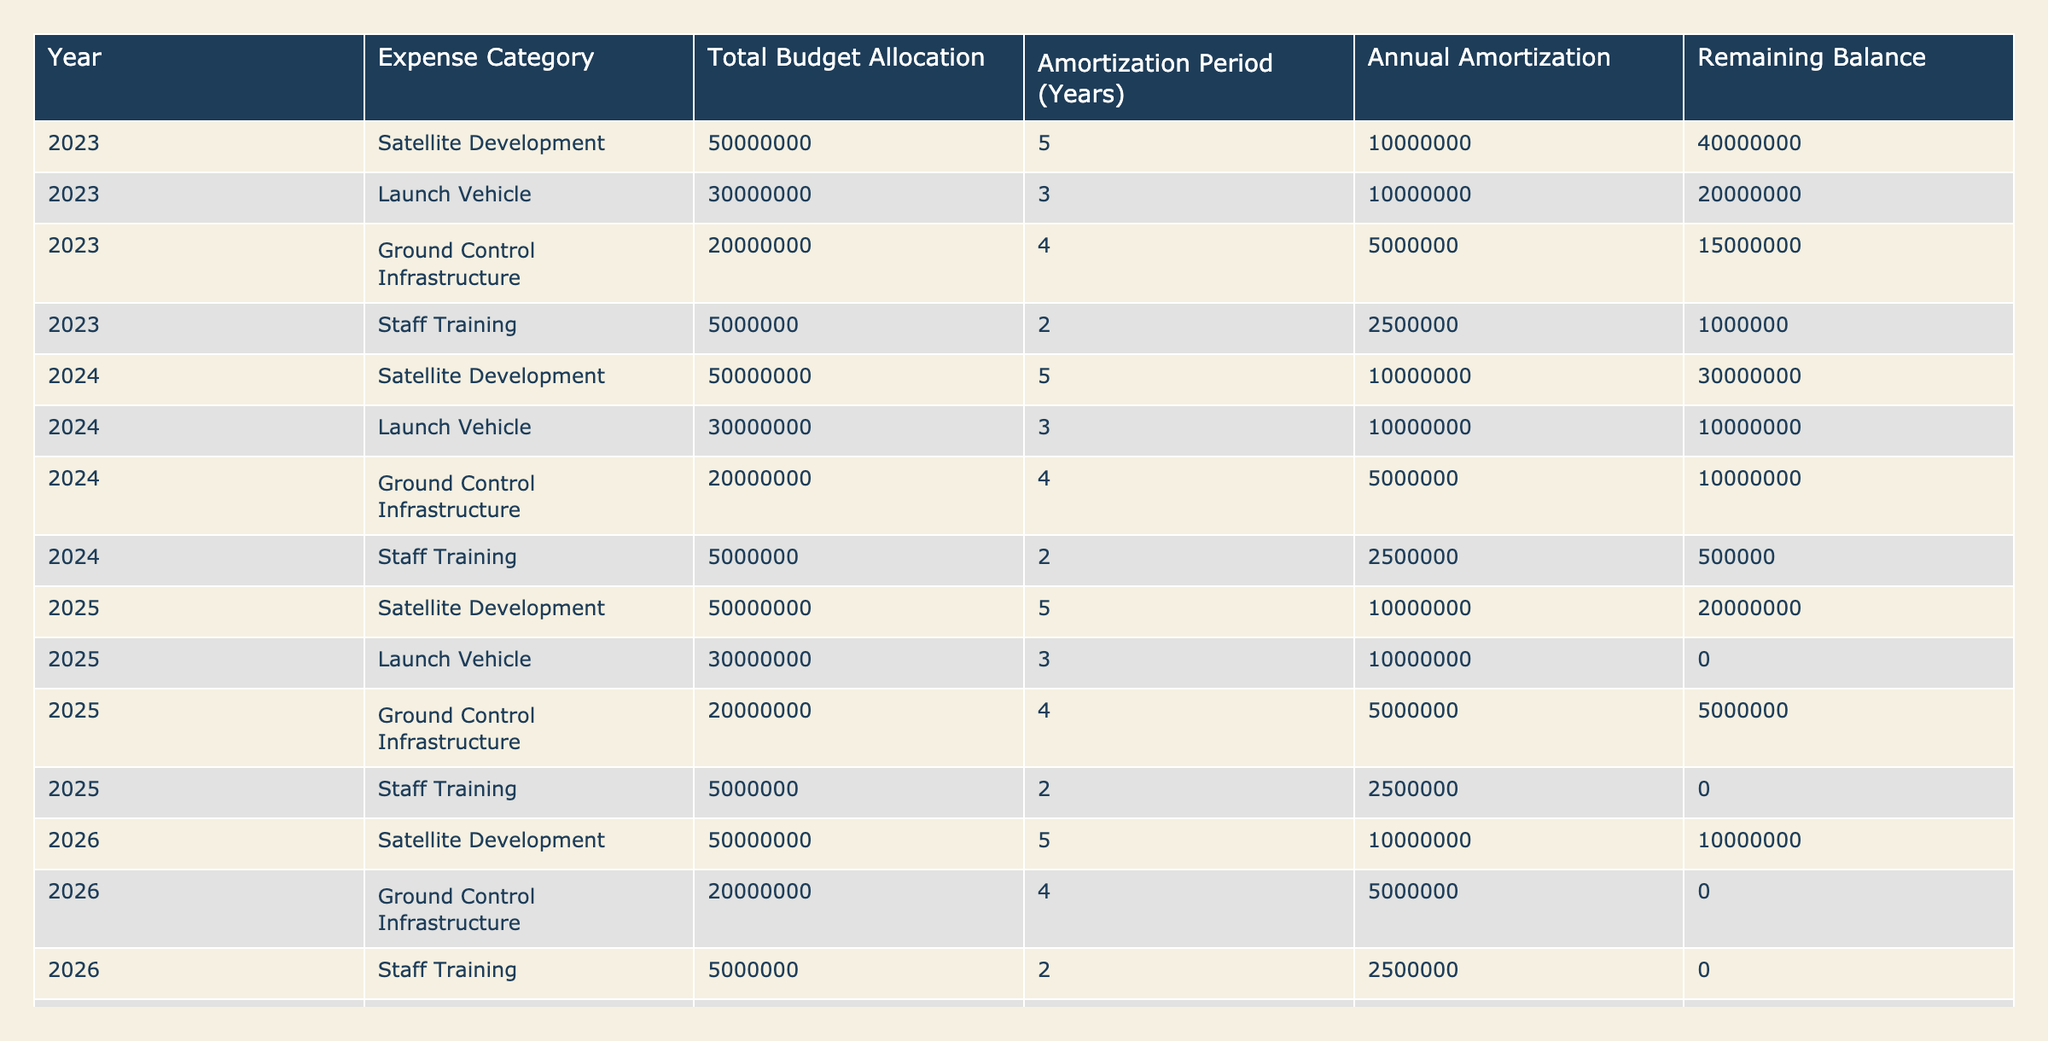What is the annual amortization for Satellite Development in 2023? In the table, we can see the row corresponding to Satellite Development for the year 2023. The column for Annual Amortization shows a value of 10000000.
Answer: 10000000 What is the remaining balance for the Launch Vehicle by the end of 2025? Looking at the table, for the Launch Vehicle, the remaining balance in 2025 is found in the row for that year, which shows a value of 0.
Answer: 0 Which expense category has the longest amortization period? To determine this, we check the Amortization Period column across all expense categories. The longest period is 5 years for the Satellite Development category.
Answer: Satellite Development What is the total remaining balance for all categories in 2024? We need to sum up the Remaining Balance values for all categories in 2024. The values are 30000000 (Satellite Development) + 10000000 (Launch Vehicle) + 10000000 (Ground Control Infrastructure) + 500000 (Staff Training) = 51000000.
Answer: 51000000 By the end of 2027, will there be any remaining balance for Ground Control Infrastructure? Checking the row for Ground Control Infrastructure, we see that by the end of 2026, the remaining balance is 0, indicating that there will be no balance left by 2027.
Answer: Yes What is the average annual amortization across all categories for 2023? First, we identify the Annual Amortization values for 2023, which are 10000000 (Satellite Development), 10000000 (Launch Vehicle), 5000000 (Ground Control Infrastructure), and 2500000 (Staff Training). The average would be calculated as (10000000 + 10000000 + 5000000 + 2500000) / 4 = 4875000.
Answer: 4875000 What is the total budget allocation for Staff Training across the years? We will look at the Total Budget Allocation values for Staff Training across all years. Each entry is 5000000, and there are 5 occurrences (one for each year until 2027), so the total would be 5 * 5000000 = 25000000.
Answer: 25000000 Is the annual amortization amount for Ground Control Infrastructure the same in 2023 and 2024? The table indicates that the Annual Amortization for Ground Control Infrastructure is 5000000 for both 2023 and 2024. Thus, the amounts are the same.
Answer: Yes 